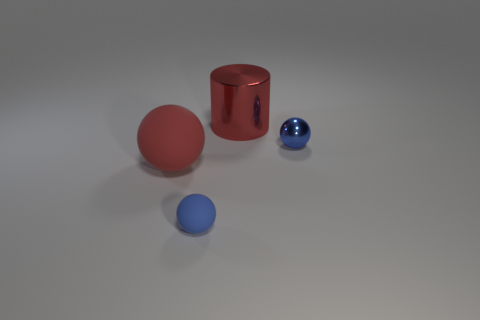Is there another green matte cylinder of the same size as the cylinder? The image only includes one cylinder, which is red and has a reflective surface. There are no green cylinders present. 